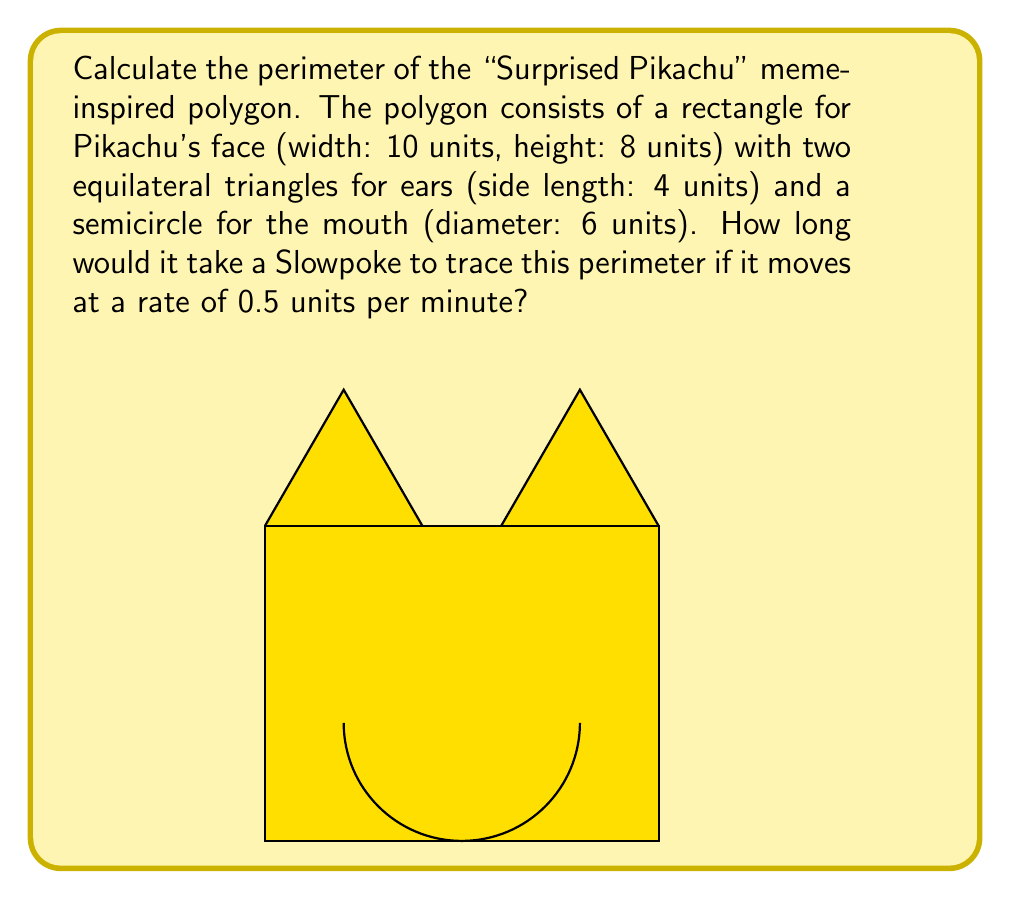Can you answer this question? Let's break this down step-by-step:

1) Calculate the perimeter of the rectangle:
   $$P_{rectangle} = 2(w + h) = 2(10 + 8) = 36$$ units

2) Calculate the perimeter of the two triangles (excluding the base):
   $$P_{triangles} = 4 * 2 = 8$$ units

3) Calculate the length of the semicircle:
   $$P_{semicircle} = \frac{1}{2} \pi d = \frac{1}{2} \pi 6 = 3\pi$$ units

4) Sum up all parts to get the total perimeter:
   $$P_{total} = 36 + 8 + 3\pi = 44 + 3\pi$$ units

5) Convert the rate to units per hour:
   $$0.5 \frac{units}{minute} * 60 \frac{minutes}{hour} = 30 \frac{units}{hour}$$

6) Calculate the time taken:
   $$T = \frac{Distance}{Rate} = \frac{44 + 3\pi}{30} = \frac{44 + 3\pi}{30}$$ hours

7) Convert to minutes:
   $$T_{minutes} = \frac{44 + 3\pi}{30} * 60 = \frac{44 + 3\pi}{0.5} = 88 + 6\pi$$ minutes
Answer: $88 + 6\pi$ minutes 